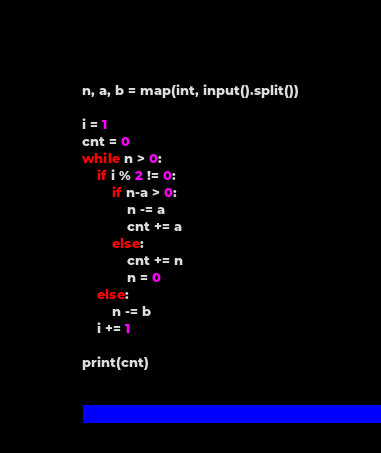<code> <loc_0><loc_0><loc_500><loc_500><_Python_>n, a, b = map(int, input().split())

i = 1
cnt = 0
while n > 0:
    if i % 2 != 0:
        if n-a > 0:
            n -= a
            cnt += a
        else:
            cnt += n
            n = 0
    else:
        n -= b
    i += 1

print(cnt)</code> 